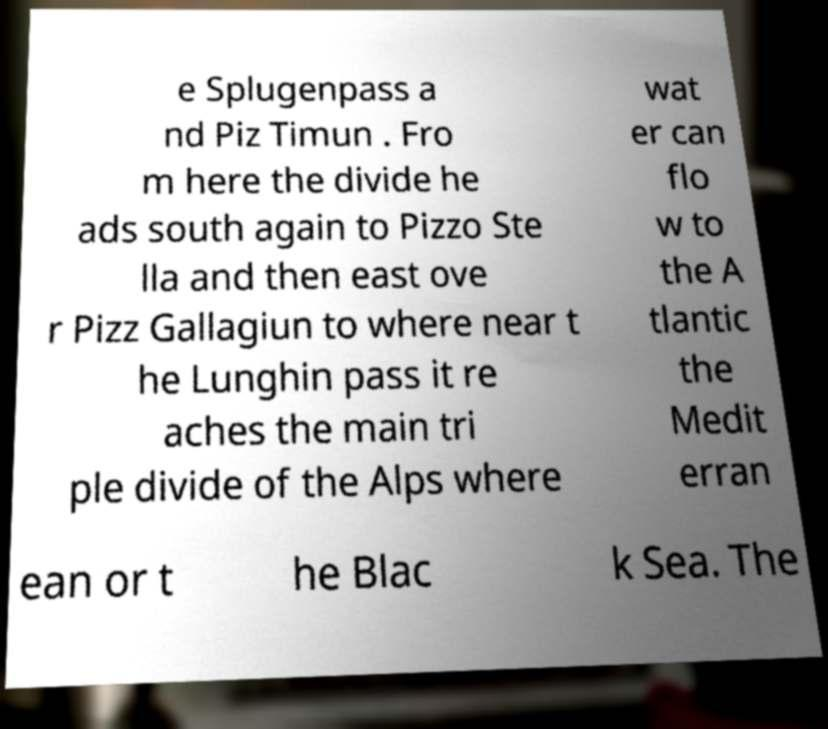There's text embedded in this image that I need extracted. Can you transcribe it verbatim? e Splugenpass a nd Piz Timun . Fro m here the divide he ads south again to Pizzo Ste lla and then east ove r Pizz Gallagiun to where near t he Lunghin pass it re aches the main tri ple divide of the Alps where wat er can flo w to the A tlantic the Medit erran ean or t he Blac k Sea. The 